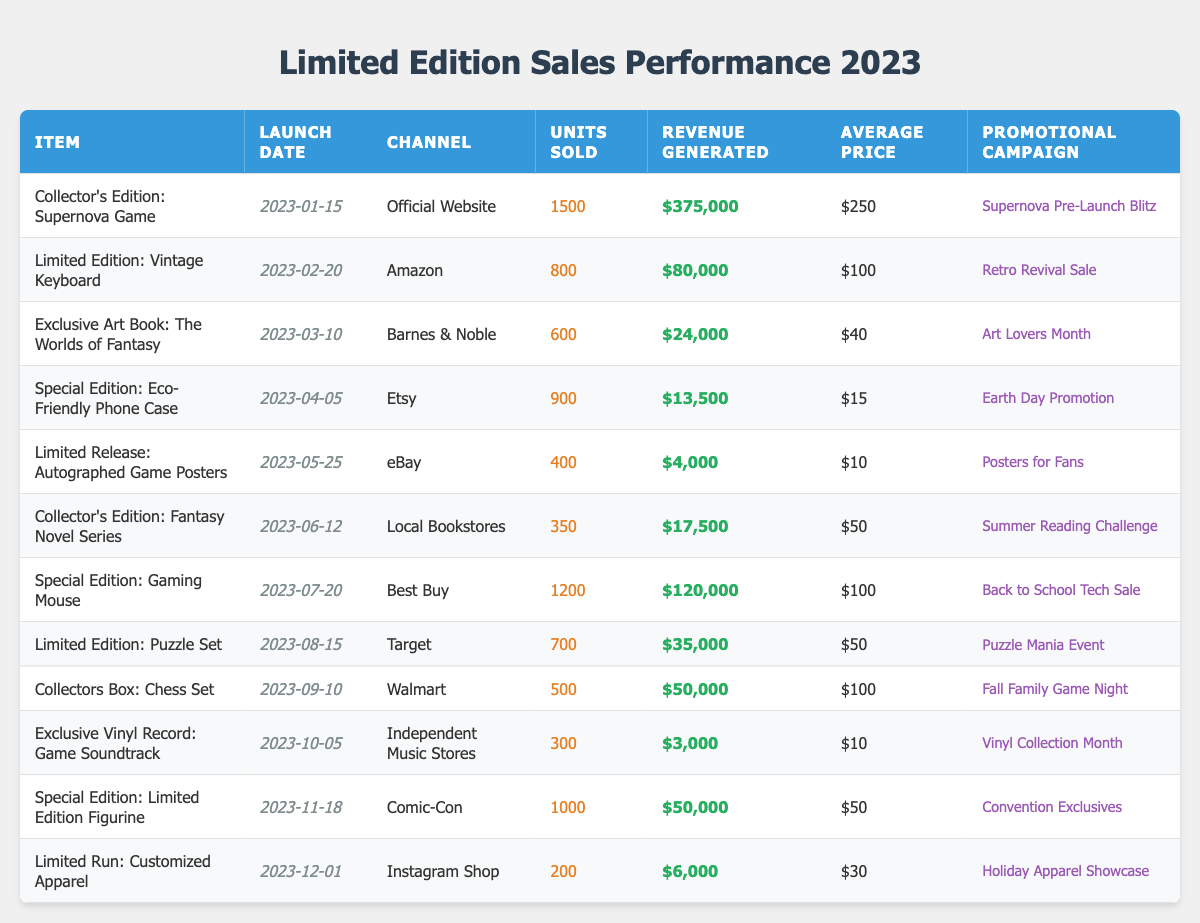What is the total number of units sold across all channels? To find the total units sold, sum the Units Sold column. Adding the values gives: 1500 + 800 + 600 + 900 + 400 + 350 + 1200 + 700 + 500 + 300 + 1000 + 200 = 6,850
Answer: 6,850 Which promotional campaign generated the highest revenue? The revenue generated by each promotional campaign can be found in the Revenue Generated column. The maximum value is $375,000 from the "Supernova Pre-Launch Blitz" campaign for the Collector's Edition: Supernova Game
Answer: Supernova Pre-Launch Blitz How many items were launched in the first half of 2023? Items launched between January and June 2023 are: Collector's Edition: Supernova Game, Limited Edition: Vintage Keyboard, Exclusive Art Book: The Worlds of Fantasy, Special Edition: Eco-Friendly Phone Case, Collector's Edition: Fantasy Novel Series. Counting these gives a total of 5 items
Answer: 5 What is the average price of items sold through Amazon? The average price is calculated by taking the Average Price of items sold through Amazon. There is one item (Limited Edition: Vintage Keyboard) with an average price of $100. Since there’s only one item, the average price remains $100
Answer: $100 Was the Special Edition: Eco-Friendly Phone Case more popular than the Limited Release: Autographed Game Posters in terms of units sold? The units sold for the Special Edition: Eco-Friendly Phone Case is 900, while the Limited Release: Autographed Game Posters sold 400 units. Since 900 is greater than 400, it is determined that the Eco-Friendly Phone Case was more popular
Answer: Yes What is the total revenue generated from items sold at Comic-Con? The total revenue generated is obtained from the Revenue Generated column for the item sold at Comic-Con. The only item is the Special Edition: Limited Edition Figurine, which generated $50,000. Therefore, the total revenue is $50,000
Answer: $50,000 How does the average price of items sold through Walmart compare to the overall average price? First, calculate the average price for items sold through Walmart, which is from the Collectors Box: Chess Set priced at $100. Next, to find the overall average price, add all average prices: $250 + $100 + $40 + $15 + $10 + $50 + $100 + $50 + $100 + $10 + $50 + $30 = $1,005 and divide by 12 items, giving an average of $83.75. As Walmart's average price ($100) is higher than the overall average ($83.75), the comparison is made
Answer: Walmart's average price is higher What is the total number of units sold on the Official Website and Etsy combined? Units sold on the Official Website is 1500 and on Etsy is 900. Adding these gives: 1500 + 900 = 2400 units sold combined
Answer: 2400 Which item had the lowest revenue generation, and what was the amount? Checking the Revenue Generated column reveals the lowest value is $3,000 from the Exclusive Vinyl Record: Game Soundtrack
Answer: Exclusive Vinyl Record: Game Soundtrack, $3,000 How many items were sold through Best Buy and what was the revenue generated? At Best Buy, the Sold units are 1200 for the Special Edition: Gaming Mouse, and the Revenue Generated is $120,000. Thus, it confirms that 1200 units were sold generating $120,000
Answer: 1,200 units, $120,000 